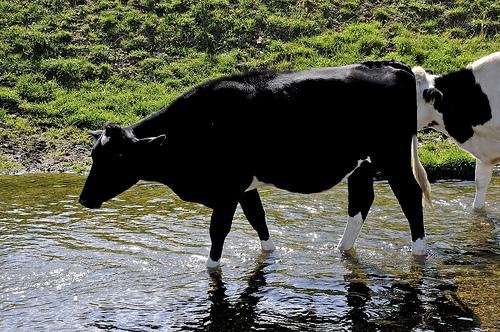Question: what are the cows walking through?
Choices:
A. Water.
B. Field.
C. Trees.
D. Mud.
Answer with the letter. Answer: A Question: why are the cows in the water?
Choices:
A. They want to cool off.
B. They are thirsty.
C. They are swimming.
D. They want to be clean.
Answer with the letter. Answer: B Question: what type of day was this?
Choices:
A. Rainy.
B. Cloudy.
C. Sunny.
D. Windy.
Answer with the letter. Answer: C 